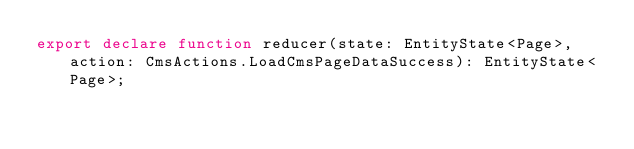Convert code to text. <code><loc_0><loc_0><loc_500><loc_500><_TypeScript_>export declare function reducer(state: EntityState<Page>, action: CmsActions.LoadCmsPageDataSuccess): EntityState<Page>;
</code> 